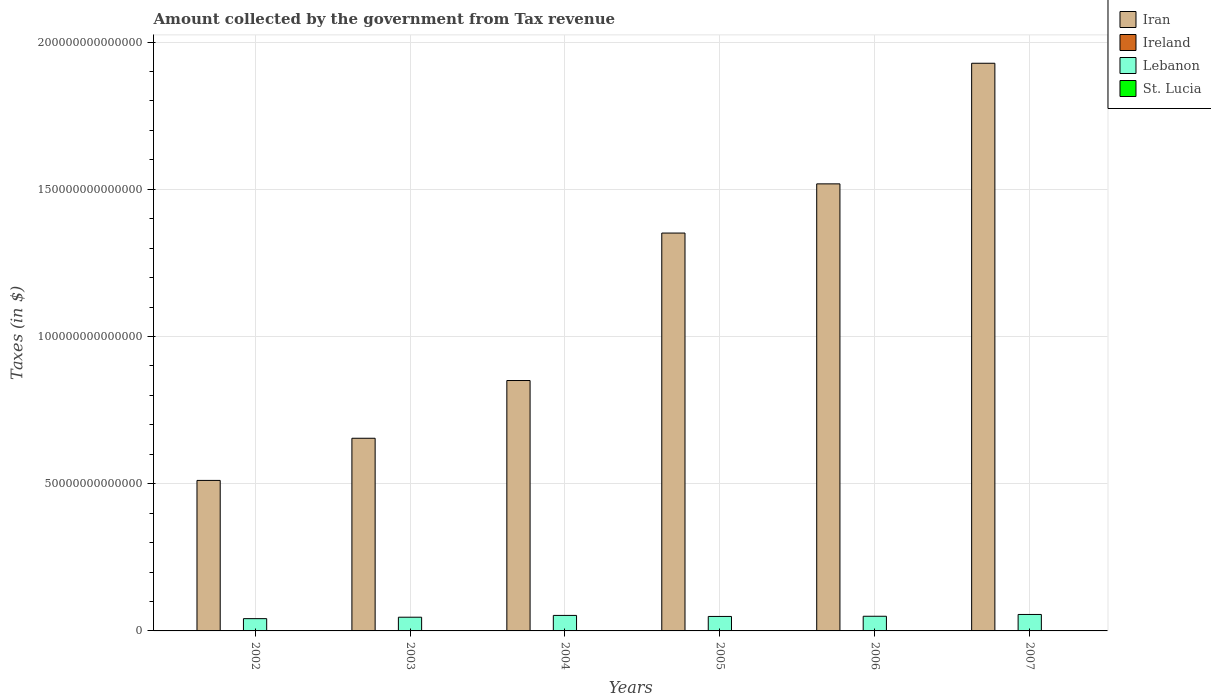How many different coloured bars are there?
Your response must be concise. 4. How many groups of bars are there?
Keep it short and to the point. 6. Are the number of bars per tick equal to the number of legend labels?
Make the answer very short. Yes. Are the number of bars on each tick of the X-axis equal?
Your response must be concise. Yes. How many bars are there on the 1st tick from the right?
Give a very brief answer. 4. What is the label of the 6th group of bars from the left?
Offer a very short reply. 2007. What is the amount collected by the government from tax revenue in Iran in 2007?
Ensure brevity in your answer.  1.93e+14. Across all years, what is the maximum amount collected by the government from tax revenue in Ireland?
Your answer should be very brief. 4.83e+1. Across all years, what is the minimum amount collected by the government from tax revenue in Iran?
Give a very brief answer. 5.11e+13. In which year was the amount collected by the government from tax revenue in Lebanon maximum?
Your answer should be compact. 2007. In which year was the amount collected by the government from tax revenue in Lebanon minimum?
Provide a short and direct response. 2002. What is the total amount collected by the government from tax revenue in Lebanon in the graph?
Provide a short and direct response. 2.96e+13. What is the difference between the amount collected by the government from tax revenue in St. Lucia in 2002 and that in 2007?
Keep it short and to the point. -2.55e+08. What is the difference between the amount collected by the government from tax revenue in Lebanon in 2003 and the amount collected by the government from tax revenue in St. Lucia in 2002?
Ensure brevity in your answer.  4.65e+12. What is the average amount collected by the government from tax revenue in Ireland per year?
Provide a succinct answer. 3.94e+1. In the year 2006, what is the difference between the amount collected by the government from tax revenue in Ireland and amount collected by the government from tax revenue in Iran?
Offer a terse response. -1.52e+14. In how many years, is the amount collected by the government from tax revenue in Ireland greater than 190000000000000 $?
Offer a terse response. 0. What is the ratio of the amount collected by the government from tax revenue in Ireland in 2005 to that in 2007?
Provide a short and direct response. 0.84. What is the difference between the highest and the second highest amount collected by the government from tax revenue in Lebanon?
Keep it short and to the point. 3.27e+11. What is the difference between the highest and the lowest amount collected by the government from tax revenue in Ireland?
Keep it short and to the point. 1.81e+1. In how many years, is the amount collected by the government from tax revenue in Iran greater than the average amount collected by the government from tax revenue in Iran taken over all years?
Your answer should be compact. 3. Is the sum of the amount collected by the government from tax revenue in Lebanon in 2002 and 2007 greater than the maximum amount collected by the government from tax revenue in St. Lucia across all years?
Offer a very short reply. Yes. Is it the case that in every year, the sum of the amount collected by the government from tax revenue in Ireland and amount collected by the government from tax revenue in St. Lucia is greater than the sum of amount collected by the government from tax revenue in Iran and amount collected by the government from tax revenue in Lebanon?
Give a very brief answer. No. What does the 3rd bar from the left in 2002 represents?
Offer a very short reply. Lebanon. What does the 4th bar from the right in 2005 represents?
Your answer should be very brief. Iran. How many bars are there?
Keep it short and to the point. 24. Are all the bars in the graph horizontal?
Make the answer very short. No. How many years are there in the graph?
Offer a very short reply. 6. What is the difference between two consecutive major ticks on the Y-axis?
Provide a succinct answer. 5.00e+13. Does the graph contain any zero values?
Make the answer very short. No. How many legend labels are there?
Offer a terse response. 4. What is the title of the graph?
Keep it short and to the point. Amount collected by the government from Tax revenue. What is the label or title of the X-axis?
Ensure brevity in your answer.  Years. What is the label or title of the Y-axis?
Keep it short and to the point. Taxes (in $). What is the Taxes (in $) in Iran in 2002?
Keep it short and to the point. 5.11e+13. What is the Taxes (in $) in Ireland in 2002?
Offer a very short reply. 3.02e+1. What is the Taxes (in $) in Lebanon in 2002?
Ensure brevity in your answer.  4.17e+12. What is the Taxes (in $) in St. Lucia in 2002?
Offer a very short reply. 4.48e+08. What is the Taxes (in $) in Iran in 2003?
Ensure brevity in your answer.  6.54e+13. What is the Taxes (in $) in Ireland in 2003?
Ensure brevity in your answer.  3.31e+1. What is the Taxes (in $) of Lebanon in 2003?
Keep it short and to the point. 4.66e+12. What is the Taxes (in $) in St. Lucia in 2003?
Offer a terse response. 4.67e+08. What is the Taxes (in $) in Iran in 2004?
Provide a succinct answer. 8.50e+13. What is the Taxes (in $) in Ireland in 2004?
Provide a short and direct response. 3.70e+1. What is the Taxes (in $) of Lebanon in 2004?
Your answer should be compact. 5.27e+12. What is the Taxes (in $) in St. Lucia in 2004?
Keep it short and to the point. 5.38e+08. What is the Taxes (in $) of Iran in 2005?
Your answer should be very brief. 1.35e+14. What is the Taxes (in $) in Ireland in 2005?
Offer a very short reply. 4.07e+1. What is the Taxes (in $) of Lebanon in 2005?
Your response must be concise. 4.92e+12. What is the Taxes (in $) in St. Lucia in 2005?
Offer a very short reply. 5.77e+08. What is the Taxes (in $) of Iran in 2006?
Offer a very short reply. 1.52e+14. What is the Taxes (in $) in Ireland in 2006?
Make the answer very short. 4.69e+1. What is the Taxes (in $) in Lebanon in 2006?
Provide a short and direct response. 4.98e+12. What is the Taxes (in $) of St. Lucia in 2006?
Offer a very short reply. 6.48e+08. What is the Taxes (in $) in Iran in 2007?
Your answer should be compact. 1.93e+14. What is the Taxes (in $) in Ireland in 2007?
Provide a short and direct response. 4.83e+1. What is the Taxes (in $) of Lebanon in 2007?
Offer a very short reply. 5.59e+12. What is the Taxes (in $) in St. Lucia in 2007?
Your answer should be compact. 7.03e+08. Across all years, what is the maximum Taxes (in $) of Iran?
Offer a terse response. 1.93e+14. Across all years, what is the maximum Taxes (in $) of Ireland?
Your response must be concise. 4.83e+1. Across all years, what is the maximum Taxes (in $) of Lebanon?
Keep it short and to the point. 5.59e+12. Across all years, what is the maximum Taxes (in $) of St. Lucia?
Ensure brevity in your answer.  7.03e+08. Across all years, what is the minimum Taxes (in $) in Iran?
Ensure brevity in your answer.  5.11e+13. Across all years, what is the minimum Taxes (in $) in Ireland?
Give a very brief answer. 3.02e+1. Across all years, what is the minimum Taxes (in $) of Lebanon?
Provide a succinct answer. 4.17e+12. Across all years, what is the minimum Taxes (in $) of St. Lucia?
Offer a terse response. 4.48e+08. What is the total Taxes (in $) of Iran in the graph?
Provide a short and direct response. 6.81e+14. What is the total Taxes (in $) in Ireland in the graph?
Provide a short and direct response. 2.36e+11. What is the total Taxes (in $) of Lebanon in the graph?
Keep it short and to the point. 2.96e+13. What is the total Taxes (in $) in St. Lucia in the graph?
Provide a succinct answer. 3.38e+09. What is the difference between the Taxes (in $) of Iran in 2002 and that in 2003?
Ensure brevity in your answer.  -1.43e+13. What is the difference between the Taxes (in $) of Ireland in 2002 and that in 2003?
Provide a succinct answer. -2.84e+09. What is the difference between the Taxes (in $) of Lebanon in 2002 and that in 2003?
Ensure brevity in your answer.  -4.89e+11. What is the difference between the Taxes (in $) in St. Lucia in 2002 and that in 2003?
Provide a short and direct response. -1.81e+07. What is the difference between the Taxes (in $) of Iran in 2002 and that in 2004?
Ensure brevity in your answer.  -3.39e+13. What is the difference between the Taxes (in $) in Ireland in 2002 and that in 2004?
Keep it short and to the point. -6.72e+09. What is the difference between the Taxes (in $) of Lebanon in 2002 and that in 2004?
Make the answer very short. -1.10e+12. What is the difference between the Taxes (in $) in St. Lucia in 2002 and that in 2004?
Ensure brevity in your answer.  -8.94e+07. What is the difference between the Taxes (in $) in Iran in 2002 and that in 2005?
Your answer should be compact. -8.40e+13. What is the difference between the Taxes (in $) of Ireland in 2002 and that in 2005?
Ensure brevity in your answer.  -1.05e+1. What is the difference between the Taxes (in $) in Lebanon in 2002 and that in 2005?
Ensure brevity in your answer.  -7.49e+11. What is the difference between the Taxes (in $) in St. Lucia in 2002 and that in 2005?
Provide a short and direct response. -1.28e+08. What is the difference between the Taxes (in $) of Iran in 2002 and that in 2006?
Offer a terse response. -1.01e+14. What is the difference between the Taxes (in $) in Ireland in 2002 and that in 2006?
Keep it short and to the point. -1.66e+1. What is the difference between the Taxes (in $) of Lebanon in 2002 and that in 2006?
Your response must be concise. -8.16e+11. What is the difference between the Taxes (in $) of St. Lucia in 2002 and that in 2006?
Your answer should be compact. -1.99e+08. What is the difference between the Taxes (in $) of Iran in 2002 and that in 2007?
Keep it short and to the point. -1.42e+14. What is the difference between the Taxes (in $) in Ireland in 2002 and that in 2007?
Offer a terse response. -1.81e+1. What is the difference between the Taxes (in $) in Lebanon in 2002 and that in 2007?
Offer a terse response. -1.43e+12. What is the difference between the Taxes (in $) of St. Lucia in 2002 and that in 2007?
Keep it short and to the point. -2.55e+08. What is the difference between the Taxes (in $) of Iran in 2003 and that in 2004?
Provide a succinct answer. -1.96e+13. What is the difference between the Taxes (in $) in Ireland in 2003 and that in 2004?
Provide a succinct answer. -3.88e+09. What is the difference between the Taxes (in $) of Lebanon in 2003 and that in 2004?
Offer a very short reply. -6.11e+11. What is the difference between the Taxes (in $) of St. Lucia in 2003 and that in 2004?
Your answer should be compact. -7.13e+07. What is the difference between the Taxes (in $) in Iran in 2003 and that in 2005?
Your response must be concise. -6.97e+13. What is the difference between the Taxes (in $) in Ireland in 2003 and that in 2005?
Provide a short and direct response. -7.67e+09. What is the difference between the Taxes (in $) in Lebanon in 2003 and that in 2005?
Provide a succinct answer. -2.60e+11. What is the difference between the Taxes (in $) of St. Lucia in 2003 and that in 2005?
Your answer should be compact. -1.10e+08. What is the difference between the Taxes (in $) in Iran in 2003 and that in 2006?
Provide a short and direct response. -8.64e+13. What is the difference between the Taxes (in $) in Ireland in 2003 and that in 2006?
Provide a succinct answer. -1.38e+1. What is the difference between the Taxes (in $) in Lebanon in 2003 and that in 2006?
Your answer should be compact. -3.27e+11. What is the difference between the Taxes (in $) of St. Lucia in 2003 and that in 2006?
Your answer should be very brief. -1.81e+08. What is the difference between the Taxes (in $) of Iran in 2003 and that in 2007?
Provide a short and direct response. -1.27e+14. What is the difference between the Taxes (in $) of Ireland in 2003 and that in 2007?
Your answer should be very brief. -1.52e+1. What is the difference between the Taxes (in $) in Lebanon in 2003 and that in 2007?
Ensure brevity in your answer.  -9.38e+11. What is the difference between the Taxes (in $) of St. Lucia in 2003 and that in 2007?
Keep it short and to the point. -2.37e+08. What is the difference between the Taxes (in $) of Iran in 2004 and that in 2005?
Give a very brief answer. -5.01e+13. What is the difference between the Taxes (in $) in Ireland in 2004 and that in 2005?
Your answer should be very brief. -3.79e+09. What is the difference between the Taxes (in $) of Lebanon in 2004 and that in 2005?
Provide a succinct answer. 3.50e+11. What is the difference between the Taxes (in $) in St. Lucia in 2004 and that in 2005?
Offer a very short reply. -3.90e+07. What is the difference between the Taxes (in $) in Iran in 2004 and that in 2006?
Offer a terse response. -6.68e+13. What is the difference between the Taxes (in $) of Ireland in 2004 and that in 2006?
Give a very brief answer. -9.90e+09. What is the difference between the Taxes (in $) in Lebanon in 2004 and that in 2006?
Your response must be concise. 2.83e+11. What is the difference between the Taxes (in $) of St. Lucia in 2004 and that in 2006?
Ensure brevity in your answer.  -1.10e+08. What is the difference between the Taxes (in $) in Iran in 2004 and that in 2007?
Your answer should be very brief. -1.08e+14. What is the difference between the Taxes (in $) of Ireland in 2004 and that in 2007?
Keep it short and to the point. -1.14e+1. What is the difference between the Taxes (in $) of Lebanon in 2004 and that in 2007?
Ensure brevity in your answer.  -3.27e+11. What is the difference between the Taxes (in $) in St. Lucia in 2004 and that in 2007?
Your response must be concise. -1.66e+08. What is the difference between the Taxes (in $) in Iran in 2005 and that in 2006?
Make the answer very short. -1.67e+13. What is the difference between the Taxes (in $) of Ireland in 2005 and that in 2006?
Your response must be concise. -6.11e+09. What is the difference between the Taxes (in $) in Lebanon in 2005 and that in 2006?
Your response must be concise. -6.71e+1. What is the difference between the Taxes (in $) of St. Lucia in 2005 and that in 2006?
Make the answer very short. -7.09e+07. What is the difference between the Taxes (in $) in Iran in 2005 and that in 2007?
Your answer should be compact. -5.77e+13. What is the difference between the Taxes (in $) in Ireland in 2005 and that in 2007?
Offer a terse response. -7.58e+09. What is the difference between the Taxes (in $) of Lebanon in 2005 and that in 2007?
Give a very brief answer. -6.78e+11. What is the difference between the Taxes (in $) of St. Lucia in 2005 and that in 2007?
Give a very brief answer. -1.26e+08. What is the difference between the Taxes (in $) in Iran in 2006 and that in 2007?
Give a very brief answer. -4.10e+13. What is the difference between the Taxes (in $) in Ireland in 2006 and that in 2007?
Keep it short and to the point. -1.47e+09. What is the difference between the Taxes (in $) of Lebanon in 2006 and that in 2007?
Offer a terse response. -6.11e+11. What is the difference between the Taxes (in $) in St. Lucia in 2006 and that in 2007?
Offer a very short reply. -5.56e+07. What is the difference between the Taxes (in $) in Iran in 2002 and the Taxes (in $) in Ireland in 2003?
Offer a very short reply. 5.11e+13. What is the difference between the Taxes (in $) of Iran in 2002 and the Taxes (in $) of Lebanon in 2003?
Offer a terse response. 4.65e+13. What is the difference between the Taxes (in $) of Iran in 2002 and the Taxes (in $) of St. Lucia in 2003?
Your answer should be compact. 5.11e+13. What is the difference between the Taxes (in $) in Ireland in 2002 and the Taxes (in $) in Lebanon in 2003?
Your answer should be very brief. -4.63e+12. What is the difference between the Taxes (in $) in Ireland in 2002 and the Taxes (in $) in St. Lucia in 2003?
Give a very brief answer. 2.98e+1. What is the difference between the Taxes (in $) of Lebanon in 2002 and the Taxes (in $) of St. Lucia in 2003?
Offer a terse response. 4.17e+12. What is the difference between the Taxes (in $) of Iran in 2002 and the Taxes (in $) of Ireland in 2004?
Make the answer very short. 5.11e+13. What is the difference between the Taxes (in $) in Iran in 2002 and the Taxes (in $) in Lebanon in 2004?
Give a very brief answer. 4.59e+13. What is the difference between the Taxes (in $) of Iran in 2002 and the Taxes (in $) of St. Lucia in 2004?
Your answer should be very brief. 5.11e+13. What is the difference between the Taxes (in $) in Ireland in 2002 and the Taxes (in $) in Lebanon in 2004?
Your response must be concise. -5.24e+12. What is the difference between the Taxes (in $) of Ireland in 2002 and the Taxes (in $) of St. Lucia in 2004?
Offer a terse response. 2.97e+1. What is the difference between the Taxes (in $) in Lebanon in 2002 and the Taxes (in $) in St. Lucia in 2004?
Keep it short and to the point. 4.17e+12. What is the difference between the Taxes (in $) of Iran in 2002 and the Taxes (in $) of Ireland in 2005?
Provide a succinct answer. 5.11e+13. What is the difference between the Taxes (in $) in Iran in 2002 and the Taxes (in $) in Lebanon in 2005?
Make the answer very short. 4.62e+13. What is the difference between the Taxes (in $) in Iran in 2002 and the Taxes (in $) in St. Lucia in 2005?
Your answer should be compact. 5.11e+13. What is the difference between the Taxes (in $) of Ireland in 2002 and the Taxes (in $) of Lebanon in 2005?
Provide a short and direct response. -4.89e+12. What is the difference between the Taxes (in $) in Ireland in 2002 and the Taxes (in $) in St. Lucia in 2005?
Offer a terse response. 2.97e+1. What is the difference between the Taxes (in $) of Lebanon in 2002 and the Taxes (in $) of St. Lucia in 2005?
Ensure brevity in your answer.  4.17e+12. What is the difference between the Taxes (in $) of Iran in 2002 and the Taxes (in $) of Ireland in 2006?
Make the answer very short. 5.11e+13. What is the difference between the Taxes (in $) of Iran in 2002 and the Taxes (in $) of Lebanon in 2006?
Keep it short and to the point. 4.61e+13. What is the difference between the Taxes (in $) in Iran in 2002 and the Taxes (in $) in St. Lucia in 2006?
Make the answer very short. 5.11e+13. What is the difference between the Taxes (in $) in Ireland in 2002 and the Taxes (in $) in Lebanon in 2006?
Offer a terse response. -4.95e+12. What is the difference between the Taxes (in $) of Ireland in 2002 and the Taxes (in $) of St. Lucia in 2006?
Offer a terse response. 2.96e+1. What is the difference between the Taxes (in $) of Lebanon in 2002 and the Taxes (in $) of St. Lucia in 2006?
Offer a terse response. 4.17e+12. What is the difference between the Taxes (in $) in Iran in 2002 and the Taxes (in $) in Ireland in 2007?
Your response must be concise. 5.11e+13. What is the difference between the Taxes (in $) of Iran in 2002 and the Taxes (in $) of Lebanon in 2007?
Give a very brief answer. 4.55e+13. What is the difference between the Taxes (in $) of Iran in 2002 and the Taxes (in $) of St. Lucia in 2007?
Your answer should be compact. 5.11e+13. What is the difference between the Taxes (in $) of Ireland in 2002 and the Taxes (in $) of Lebanon in 2007?
Provide a short and direct response. -5.56e+12. What is the difference between the Taxes (in $) in Ireland in 2002 and the Taxes (in $) in St. Lucia in 2007?
Your response must be concise. 2.95e+1. What is the difference between the Taxes (in $) of Lebanon in 2002 and the Taxes (in $) of St. Lucia in 2007?
Provide a short and direct response. 4.17e+12. What is the difference between the Taxes (in $) in Iran in 2003 and the Taxes (in $) in Ireland in 2004?
Give a very brief answer. 6.54e+13. What is the difference between the Taxes (in $) of Iran in 2003 and the Taxes (in $) of Lebanon in 2004?
Your response must be concise. 6.02e+13. What is the difference between the Taxes (in $) of Iran in 2003 and the Taxes (in $) of St. Lucia in 2004?
Your answer should be compact. 6.54e+13. What is the difference between the Taxes (in $) of Ireland in 2003 and the Taxes (in $) of Lebanon in 2004?
Provide a succinct answer. -5.23e+12. What is the difference between the Taxes (in $) of Ireland in 2003 and the Taxes (in $) of St. Lucia in 2004?
Give a very brief answer. 3.25e+1. What is the difference between the Taxes (in $) in Lebanon in 2003 and the Taxes (in $) in St. Lucia in 2004?
Provide a short and direct response. 4.65e+12. What is the difference between the Taxes (in $) in Iran in 2003 and the Taxes (in $) in Ireland in 2005?
Your response must be concise. 6.54e+13. What is the difference between the Taxes (in $) in Iran in 2003 and the Taxes (in $) in Lebanon in 2005?
Keep it short and to the point. 6.05e+13. What is the difference between the Taxes (in $) of Iran in 2003 and the Taxes (in $) of St. Lucia in 2005?
Offer a terse response. 6.54e+13. What is the difference between the Taxes (in $) of Ireland in 2003 and the Taxes (in $) of Lebanon in 2005?
Your answer should be very brief. -4.88e+12. What is the difference between the Taxes (in $) of Ireland in 2003 and the Taxes (in $) of St. Lucia in 2005?
Ensure brevity in your answer.  3.25e+1. What is the difference between the Taxes (in $) of Lebanon in 2003 and the Taxes (in $) of St. Lucia in 2005?
Make the answer very short. 4.65e+12. What is the difference between the Taxes (in $) in Iran in 2003 and the Taxes (in $) in Ireland in 2006?
Offer a terse response. 6.54e+13. What is the difference between the Taxes (in $) in Iran in 2003 and the Taxes (in $) in Lebanon in 2006?
Ensure brevity in your answer.  6.05e+13. What is the difference between the Taxes (in $) of Iran in 2003 and the Taxes (in $) of St. Lucia in 2006?
Ensure brevity in your answer.  6.54e+13. What is the difference between the Taxes (in $) of Ireland in 2003 and the Taxes (in $) of Lebanon in 2006?
Ensure brevity in your answer.  -4.95e+12. What is the difference between the Taxes (in $) of Ireland in 2003 and the Taxes (in $) of St. Lucia in 2006?
Keep it short and to the point. 3.24e+1. What is the difference between the Taxes (in $) of Lebanon in 2003 and the Taxes (in $) of St. Lucia in 2006?
Your response must be concise. 4.65e+12. What is the difference between the Taxes (in $) of Iran in 2003 and the Taxes (in $) of Ireland in 2007?
Ensure brevity in your answer.  6.54e+13. What is the difference between the Taxes (in $) of Iran in 2003 and the Taxes (in $) of Lebanon in 2007?
Your answer should be compact. 5.98e+13. What is the difference between the Taxes (in $) in Iran in 2003 and the Taxes (in $) in St. Lucia in 2007?
Give a very brief answer. 6.54e+13. What is the difference between the Taxes (in $) of Ireland in 2003 and the Taxes (in $) of Lebanon in 2007?
Offer a very short reply. -5.56e+12. What is the difference between the Taxes (in $) in Ireland in 2003 and the Taxes (in $) in St. Lucia in 2007?
Make the answer very short. 3.24e+1. What is the difference between the Taxes (in $) of Lebanon in 2003 and the Taxes (in $) of St. Lucia in 2007?
Offer a very short reply. 4.65e+12. What is the difference between the Taxes (in $) of Iran in 2004 and the Taxes (in $) of Ireland in 2005?
Provide a short and direct response. 8.50e+13. What is the difference between the Taxes (in $) of Iran in 2004 and the Taxes (in $) of Lebanon in 2005?
Make the answer very short. 8.01e+13. What is the difference between the Taxes (in $) of Iran in 2004 and the Taxes (in $) of St. Lucia in 2005?
Provide a short and direct response. 8.50e+13. What is the difference between the Taxes (in $) in Ireland in 2004 and the Taxes (in $) in Lebanon in 2005?
Ensure brevity in your answer.  -4.88e+12. What is the difference between the Taxes (in $) in Ireland in 2004 and the Taxes (in $) in St. Lucia in 2005?
Your answer should be very brief. 3.64e+1. What is the difference between the Taxes (in $) of Lebanon in 2004 and the Taxes (in $) of St. Lucia in 2005?
Provide a short and direct response. 5.27e+12. What is the difference between the Taxes (in $) of Iran in 2004 and the Taxes (in $) of Ireland in 2006?
Offer a terse response. 8.50e+13. What is the difference between the Taxes (in $) of Iran in 2004 and the Taxes (in $) of Lebanon in 2006?
Offer a terse response. 8.01e+13. What is the difference between the Taxes (in $) of Iran in 2004 and the Taxes (in $) of St. Lucia in 2006?
Provide a short and direct response. 8.50e+13. What is the difference between the Taxes (in $) in Ireland in 2004 and the Taxes (in $) in Lebanon in 2006?
Provide a succinct answer. -4.95e+12. What is the difference between the Taxes (in $) of Ireland in 2004 and the Taxes (in $) of St. Lucia in 2006?
Offer a terse response. 3.63e+1. What is the difference between the Taxes (in $) of Lebanon in 2004 and the Taxes (in $) of St. Lucia in 2006?
Ensure brevity in your answer.  5.27e+12. What is the difference between the Taxes (in $) of Iran in 2004 and the Taxes (in $) of Ireland in 2007?
Keep it short and to the point. 8.50e+13. What is the difference between the Taxes (in $) of Iran in 2004 and the Taxes (in $) of Lebanon in 2007?
Make the answer very short. 7.95e+13. What is the difference between the Taxes (in $) in Iran in 2004 and the Taxes (in $) in St. Lucia in 2007?
Offer a terse response. 8.50e+13. What is the difference between the Taxes (in $) of Ireland in 2004 and the Taxes (in $) of Lebanon in 2007?
Your answer should be compact. -5.56e+12. What is the difference between the Taxes (in $) of Ireland in 2004 and the Taxes (in $) of St. Lucia in 2007?
Give a very brief answer. 3.63e+1. What is the difference between the Taxes (in $) in Lebanon in 2004 and the Taxes (in $) in St. Lucia in 2007?
Provide a short and direct response. 5.27e+12. What is the difference between the Taxes (in $) in Iran in 2005 and the Taxes (in $) in Ireland in 2006?
Offer a terse response. 1.35e+14. What is the difference between the Taxes (in $) of Iran in 2005 and the Taxes (in $) of Lebanon in 2006?
Provide a succinct answer. 1.30e+14. What is the difference between the Taxes (in $) of Iran in 2005 and the Taxes (in $) of St. Lucia in 2006?
Give a very brief answer. 1.35e+14. What is the difference between the Taxes (in $) in Ireland in 2005 and the Taxes (in $) in Lebanon in 2006?
Provide a short and direct response. -4.94e+12. What is the difference between the Taxes (in $) in Ireland in 2005 and the Taxes (in $) in St. Lucia in 2006?
Keep it short and to the point. 4.01e+1. What is the difference between the Taxes (in $) of Lebanon in 2005 and the Taxes (in $) of St. Lucia in 2006?
Provide a succinct answer. 4.91e+12. What is the difference between the Taxes (in $) of Iran in 2005 and the Taxes (in $) of Ireland in 2007?
Your answer should be very brief. 1.35e+14. What is the difference between the Taxes (in $) in Iran in 2005 and the Taxes (in $) in Lebanon in 2007?
Ensure brevity in your answer.  1.30e+14. What is the difference between the Taxes (in $) of Iran in 2005 and the Taxes (in $) of St. Lucia in 2007?
Offer a very short reply. 1.35e+14. What is the difference between the Taxes (in $) in Ireland in 2005 and the Taxes (in $) in Lebanon in 2007?
Provide a succinct answer. -5.55e+12. What is the difference between the Taxes (in $) of Ireland in 2005 and the Taxes (in $) of St. Lucia in 2007?
Keep it short and to the point. 4.00e+1. What is the difference between the Taxes (in $) in Lebanon in 2005 and the Taxes (in $) in St. Lucia in 2007?
Offer a terse response. 4.91e+12. What is the difference between the Taxes (in $) of Iran in 2006 and the Taxes (in $) of Ireland in 2007?
Give a very brief answer. 1.52e+14. What is the difference between the Taxes (in $) of Iran in 2006 and the Taxes (in $) of Lebanon in 2007?
Offer a very short reply. 1.46e+14. What is the difference between the Taxes (in $) in Iran in 2006 and the Taxes (in $) in St. Lucia in 2007?
Keep it short and to the point. 1.52e+14. What is the difference between the Taxes (in $) in Ireland in 2006 and the Taxes (in $) in Lebanon in 2007?
Your answer should be very brief. -5.55e+12. What is the difference between the Taxes (in $) of Ireland in 2006 and the Taxes (in $) of St. Lucia in 2007?
Give a very brief answer. 4.61e+1. What is the difference between the Taxes (in $) in Lebanon in 2006 and the Taxes (in $) in St. Lucia in 2007?
Make the answer very short. 4.98e+12. What is the average Taxes (in $) of Iran per year?
Provide a short and direct response. 1.14e+14. What is the average Taxes (in $) in Ireland per year?
Ensure brevity in your answer.  3.94e+1. What is the average Taxes (in $) in Lebanon per year?
Keep it short and to the point. 4.93e+12. What is the average Taxes (in $) in St. Lucia per year?
Provide a succinct answer. 5.64e+08. In the year 2002, what is the difference between the Taxes (in $) in Iran and Taxes (in $) in Ireland?
Ensure brevity in your answer.  5.11e+13. In the year 2002, what is the difference between the Taxes (in $) of Iran and Taxes (in $) of Lebanon?
Offer a very short reply. 4.70e+13. In the year 2002, what is the difference between the Taxes (in $) in Iran and Taxes (in $) in St. Lucia?
Your answer should be very brief. 5.11e+13. In the year 2002, what is the difference between the Taxes (in $) in Ireland and Taxes (in $) in Lebanon?
Your response must be concise. -4.14e+12. In the year 2002, what is the difference between the Taxes (in $) of Ireland and Taxes (in $) of St. Lucia?
Keep it short and to the point. 2.98e+1. In the year 2002, what is the difference between the Taxes (in $) in Lebanon and Taxes (in $) in St. Lucia?
Your answer should be very brief. 4.17e+12. In the year 2003, what is the difference between the Taxes (in $) of Iran and Taxes (in $) of Ireland?
Your answer should be compact. 6.54e+13. In the year 2003, what is the difference between the Taxes (in $) of Iran and Taxes (in $) of Lebanon?
Provide a short and direct response. 6.08e+13. In the year 2003, what is the difference between the Taxes (in $) in Iran and Taxes (in $) in St. Lucia?
Offer a terse response. 6.54e+13. In the year 2003, what is the difference between the Taxes (in $) in Ireland and Taxes (in $) in Lebanon?
Ensure brevity in your answer.  -4.62e+12. In the year 2003, what is the difference between the Taxes (in $) of Ireland and Taxes (in $) of St. Lucia?
Your response must be concise. 3.26e+1. In the year 2003, what is the difference between the Taxes (in $) in Lebanon and Taxes (in $) in St. Lucia?
Your answer should be very brief. 4.65e+12. In the year 2004, what is the difference between the Taxes (in $) in Iran and Taxes (in $) in Ireland?
Your answer should be very brief. 8.50e+13. In the year 2004, what is the difference between the Taxes (in $) of Iran and Taxes (in $) of Lebanon?
Ensure brevity in your answer.  7.98e+13. In the year 2004, what is the difference between the Taxes (in $) in Iran and Taxes (in $) in St. Lucia?
Make the answer very short. 8.50e+13. In the year 2004, what is the difference between the Taxes (in $) of Ireland and Taxes (in $) of Lebanon?
Keep it short and to the point. -5.23e+12. In the year 2004, what is the difference between the Taxes (in $) in Ireland and Taxes (in $) in St. Lucia?
Make the answer very short. 3.64e+1. In the year 2004, what is the difference between the Taxes (in $) of Lebanon and Taxes (in $) of St. Lucia?
Your answer should be compact. 5.27e+12. In the year 2005, what is the difference between the Taxes (in $) of Iran and Taxes (in $) of Ireland?
Keep it short and to the point. 1.35e+14. In the year 2005, what is the difference between the Taxes (in $) of Iran and Taxes (in $) of Lebanon?
Keep it short and to the point. 1.30e+14. In the year 2005, what is the difference between the Taxes (in $) of Iran and Taxes (in $) of St. Lucia?
Provide a short and direct response. 1.35e+14. In the year 2005, what is the difference between the Taxes (in $) in Ireland and Taxes (in $) in Lebanon?
Your answer should be compact. -4.87e+12. In the year 2005, what is the difference between the Taxes (in $) of Ireland and Taxes (in $) of St. Lucia?
Keep it short and to the point. 4.02e+1. In the year 2005, what is the difference between the Taxes (in $) of Lebanon and Taxes (in $) of St. Lucia?
Your answer should be compact. 4.91e+12. In the year 2006, what is the difference between the Taxes (in $) of Iran and Taxes (in $) of Ireland?
Your answer should be very brief. 1.52e+14. In the year 2006, what is the difference between the Taxes (in $) of Iran and Taxes (in $) of Lebanon?
Your answer should be compact. 1.47e+14. In the year 2006, what is the difference between the Taxes (in $) in Iran and Taxes (in $) in St. Lucia?
Ensure brevity in your answer.  1.52e+14. In the year 2006, what is the difference between the Taxes (in $) in Ireland and Taxes (in $) in Lebanon?
Provide a succinct answer. -4.94e+12. In the year 2006, what is the difference between the Taxes (in $) of Ireland and Taxes (in $) of St. Lucia?
Your answer should be compact. 4.62e+1. In the year 2006, what is the difference between the Taxes (in $) of Lebanon and Taxes (in $) of St. Lucia?
Keep it short and to the point. 4.98e+12. In the year 2007, what is the difference between the Taxes (in $) of Iran and Taxes (in $) of Ireland?
Keep it short and to the point. 1.93e+14. In the year 2007, what is the difference between the Taxes (in $) in Iran and Taxes (in $) in Lebanon?
Keep it short and to the point. 1.87e+14. In the year 2007, what is the difference between the Taxes (in $) of Iran and Taxes (in $) of St. Lucia?
Keep it short and to the point. 1.93e+14. In the year 2007, what is the difference between the Taxes (in $) in Ireland and Taxes (in $) in Lebanon?
Your answer should be compact. -5.54e+12. In the year 2007, what is the difference between the Taxes (in $) in Ireland and Taxes (in $) in St. Lucia?
Ensure brevity in your answer.  4.76e+1. In the year 2007, what is the difference between the Taxes (in $) of Lebanon and Taxes (in $) of St. Lucia?
Provide a succinct answer. 5.59e+12. What is the ratio of the Taxes (in $) in Iran in 2002 to that in 2003?
Your response must be concise. 0.78. What is the ratio of the Taxes (in $) of Ireland in 2002 to that in 2003?
Make the answer very short. 0.91. What is the ratio of the Taxes (in $) of Lebanon in 2002 to that in 2003?
Provide a short and direct response. 0.9. What is the ratio of the Taxes (in $) of St. Lucia in 2002 to that in 2003?
Offer a very short reply. 0.96. What is the ratio of the Taxes (in $) in Iran in 2002 to that in 2004?
Give a very brief answer. 0.6. What is the ratio of the Taxes (in $) in Ireland in 2002 to that in 2004?
Provide a succinct answer. 0.82. What is the ratio of the Taxes (in $) in Lebanon in 2002 to that in 2004?
Offer a very short reply. 0.79. What is the ratio of the Taxes (in $) in St. Lucia in 2002 to that in 2004?
Give a very brief answer. 0.83. What is the ratio of the Taxes (in $) in Iran in 2002 to that in 2005?
Your response must be concise. 0.38. What is the ratio of the Taxes (in $) of Ireland in 2002 to that in 2005?
Ensure brevity in your answer.  0.74. What is the ratio of the Taxes (in $) in Lebanon in 2002 to that in 2005?
Ensure brevity in your answer.  0.85. What is the ratio of the Taxes (in $) in St. Lucia in 2002 to that in 2005?
Keep it short and to the point. 0.78. What is the ratio of the Taxes (in $) of Iran in 2002 to that in 2006?
Make the answer very short. 0.34. What is the ratio of the Taxes (in $) of Ireland in 2002 to that in 2006?
Provide a short and direct response. 0.65. What is the ratio of the Taxes (in $) in Lebanon in 2002 to that in 2006?
Make the answer very short. 0.84. What is the ratio of the Taxes (in $) of St. Lucia in 2002 to that in 2006?
Your response must be concise. 0.69. What is the ratio of the Taxes (in $) in Iran in 2002 to that in 2007?
Your answer should be compact. 0.27. What is the ratio of the Taxes (in $) in Ireland in 2002 to that in 2007?
Ensure brevity in your answer.  0.63. What is the ratio of the Taxes (in $) in Lebanon in 2002 to that in 2007?
Your response must be concise. 0.74. What is the ratio of the Taxes (in $) of St. Lucia in 2002 to that in 2007?
Your response must be concise. 0.64. What is the ratio of the Taxes (in $) in Iran in 2003 to that in 2004?
Your answer should be very brief. 0.77. What is the ratio of the Taxes (in $) of Ireland in 2003 to that in 2004?
Keep it short and to the point. 0.9. What is the ratio of the Taxes (in $) in Lebanon in 2003 to that in 2004?
Keep it short and to the point. 0.88. What is the ratio of the Taxes (in $) in St. Lucia in 2003 to that in 2004?
Provide a short and direct response. 0.87. What is the ratio of the Taxes (in $) of Iran in 2003 to that in 2005?
Your answer should be very brief. 0.48. What is the ratio of the Taxes (in $) in Ireland in 2003 to that in 2005?
Your answer should be compact. 0.81. What is the ratio of the Taxes (in $) in Lebanon in 2003 to that in 2005?
Provide a short and direct response. 0.95. What is the ratio of the Taxes (in $) of St. Lucia in 2003 to that in 2005?
Give a very brief answer. 0.81. What is the ratio of the Taxes (in $) of Iran in 2003 to that in 2006?
Your answer should be compact. 0.43. What is the ratio of the Taxes (in $) in Ireland in 2003 to that in 2006?
Your answer should be compact. 0.71. What is the ratio of the Taxes (in $) in Lebanon in 2003 to that in 2006?
Provide a short and direct response. 0.93. What is the ratio of the Taxes (in $) in St. Lucia in 2003 to that in 2006?
Offer a terse response. 0.72. What is the ratio of the Taxes (in $) in Iran in 2003 to that in 2007?
Provide a short and direct response. 0.34. What is the ratio of the Taxes (in $) of Ireland in 2003 to that in 2007?
Your response must be concise. 0.68. What is the ratio of the Taxes (in $) of Lebanon in 2003 to that in 2007?
Your response must be concise. 0.83. What is the ratio of the Taxes (in $) of St. Lucia in 2003 to that in 2007?
Provide a short and direct response. 0.66. What is the ratio of the Taxes (in $) of Iran in 2004 to that in 2005?
Your response must be concise. 0.63. What is the ratio of the Taxes (in $) of Ireland in 2004 to that in 2005?
Your answer should be very brief. 0.91. What is the ratio of the Taxes (in $) in Lebanon in 2004 to that in 2005?
Keep it short and to the point. 1.07. What is the ratio of the Taxes (in $) of St. Lucia in 2004 to that in 2005?
Your answer should be compact. 0.93. What is the ratio of the Taxes (in $) in Iran in 2004 to that in 2006?
Provide a succinct answer. 0.56. What is the ratio of the Taxes (in $) in Ireland in 2004 to that in 2006?
Give a very brief answer. 0.79. What is the ratio of the Taxes (in $) of Lebanon in 2004 to that in 2006?
Provide a short and direct response. 1.06. What is the ratio of the Taxes (in $) in St. Lucia in 2004 to that in 2006?
Give a very brief answer. 0.83. What is the ratio of the Taxes (in $) of Iran in 2004 to that in 2007?
Ensure brevity in your answer.  0.44. What is the ratio of the Taxes (in $) in Ireland in 2004 to that in 2007?
Make the answer very short. 0.76. What is the ratio of the Taxes (in $) of Lebanon in 2004 to that in 2007?
Your answer should be very brief. 0.94. What is the ratio of the Taxes (in $) of St. Lucia in 2004 to that in 2007?
Your response must be concise. 0.76. What is the ratio of the Taxes (in $) in Iran in 2005 to that in 2006?
Your answer should be very brief. 0.89. What is the ratio of the Taxes (in $) in Ireland in 2005 to that in 2006?
Offer a terse response. 0.87. What is the ratio of the Taxes (in $) in Lebanon in 2005 to that in 2006?
Offer a terse response. 0.99. What is the ratio of the Taxes (in $) in St. Lucia in 2005 to that in 2006?
Your answer should be compact. 0.89. What is the ratio of the Taxes (in $) of Iran in 2005 to that in 2007?
Provide a short and direct response. 0.7. What is the ratio of the Taxes (in $) of Ireland in 2005 to that in 2007?
Offer a very short reply. 0.84. What is the ratio of the Taxes (in $) in Lebanon in 2005 to that in 2007?
Keep it short and to the point. 0.88. What is the ratio of the Taxes (in $) of St. Lucia in 2005 to that in 2007?
Your answer should be compact. 0.82. What is the ratio of the Taxes (in $) in Iran in 2006 to that in 2007?
Your answer should be very brief. 0.79. What is the ratio of the Taxes (in $) in Ireland in 2006 to that in 2007?
Your answer should be very brief. 0.97. What is the ratio of the Taxes (in $) in Lebanon in 2006 to that in 2007?
Your answer should be very brief. 0.89. What is the ratio of the Taxes (in $) in St. Lucia in 2006 to that in 2007?
Give a very brief answer. 0.92. What is the difference between the highest and the second highest Taxes (in $) of Iran?
Give a very brief answer. 4.10e+13. What is the difference between the highest and the second highest Taxes (in $) of Ireland?
Your response must be concise. 1.47e+09. What is the difference between the highest and the second highest Taxes (in $) in Lebanon?
Your answer should be very brief. 3.27e+11. What is the difference between the highest and the second highest Taxes (in $) in St. Lucia?
Offer a terse response. 5.56e+07. What is the difference between the highest and the lowest Taxes (in $) of Iran?
Make the answer very short. 1.42e+14. What is the difference between the highest and the lowest Taxes (in $) in Ireland?
Your answer should be very brief. 1.81e+1. What is the difference between the highest and the lowest Taxes (in $) of Lebanon?
Make the answer very short. 1.43e+12. What is the difference between the highest and the lowest Taxes (in $) of St. Lucia?
Give a very brief answer. 2.55e+08. 